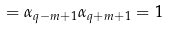Convert formula to latex. <formula><loc_0><loc_0><loc_500><loc_500>= \alpha _ { q - m + 1 } \alpha _ { q + m + 1 } = 1</formula> 